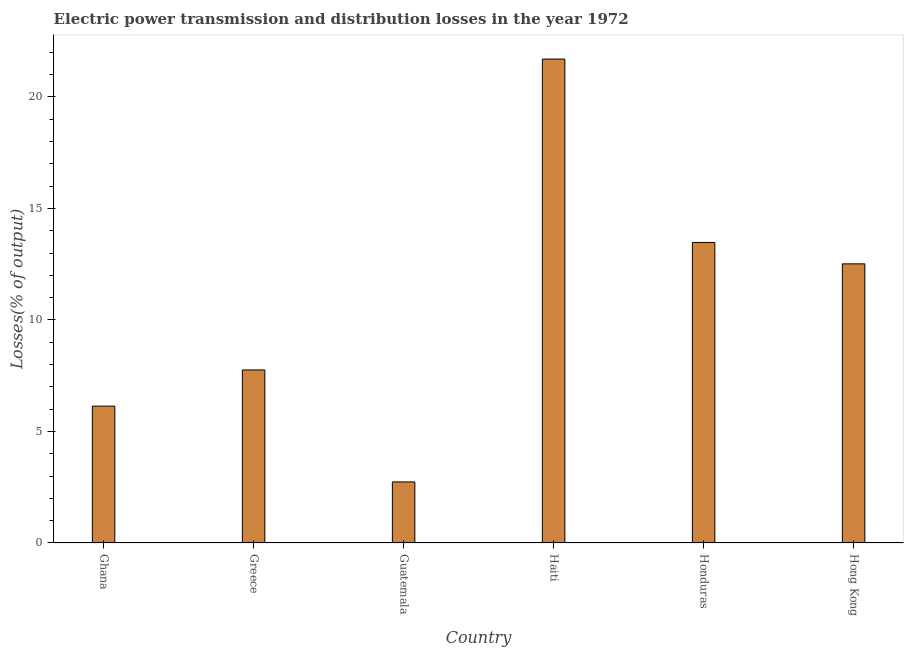What is the title of the graph?
Offer a very short reply. Electric power transmission and distribution losses in the year 1972. What is the label or title of the Y-axis?
Offer a very short reply. Losses(% of output). What is the electric power transmission and distribution losses in Honduras?
Your answer should be compact. 13.48. Across all countries, what is the maximum electric power transmission and distribution losses?
Offer a very short reply. 21.7. Across all countries, what is the minimum electric power transmission and distribution losses?
Keep it short and to the point. 2.74. In which country was the electric power transmission and distribution losses maximum?
Make the answer very short. Haiti. In which country was the electric power transmission and distribution losses minimum?
Make the answer very short. Guatemala. What is the sum of the electric power transmission and distribution losses?
Ensure brevity in your answer.  64.32. What is the difference between the electric power transmission and distribution losses in Haiti and Hong Kong?
Your response must be concise. 9.18. What is the average electric power transmission and distribution losses per country?
Make the answer very short. 10.72. What is the median electric power transmission and distribution losses?
Your answer should be very brief. 10.14. What is the ratio of the electric power transmission and distribution losses in Guatemala to that in Haiti?
Make the answer very short. 0.13. Is the electric power transmission and distribution losses in Guatemala less than that in Haiti?
Your response must be concise. Yes. Is the difference between the electric power transmission and distribution losses in Ghana and Guatemala greater than the difference between any two countries?
Your response must be concise. No. What is the difference between the highest and the second highest electric power transmission and distribution losses?
Keep it short and to the point. 8.22. What is the difference between the highest and the lowest electric power transmission and distribution losses?
Provide a succinct answer. 18.96. How many bars are there?
Offer a terse response. 6. How many countries are there in the graph?
Offer a very short reply. 6. What is the difference between two consecutive major ticks on the Y-axis?
Your answer should be compact. 5. What is the Losses(% of output) in Ghana?
Offer a very short reply. 6.14. What is the Losses(% of output) in Greece?
Ensure brevity in your answer.  7.76. What is the Losses(% of output) in Guatemala?
Provide a short and direct response. 2.74. What is the Losses(% of output) of Haiti?
Keep it short and to the point. 21.7. What is the Losses(% of output) in Honduras?
Give a very brief answer. 13.48. What is the Losses(% of output) of Hong Kong?
Offer a terse response. 12.52. What is the difference between the Losses(% of output) in Ghana and Greece?
Keep it short and to the point. -1.62. What is the difference between the Losses(% of output) in Ghana and Guatemala?
Provide a succinct answer. 3.4. What is the difference between the Losses(% of output) in Ghana and Haiti?
Provide a succinct answer. -15.56. What is the difference between the Losses(% of output) in Ghana and Honduras?
Provide a short and direct response. -7.34. What is the difference between the Losses(% of output) in Ghana and Hong Kong?
Ensure brevity in your answer.  -6.38. What is the difference between the Losses(% of output) in Greece and Guatemala?
Make the answer very short. 5.02. What is the difference between the Losses(% of output) in Greece and Haiti?
Your answer should be very brief. -13.94. What is the difference between the Losses(% of output) in Greece and Honduras?
Your response must be concise. -5.72. What is the difference between the Losses(% of output) in Greece and Hong Kong?
Offer a very short reply. -4.76. What is the difference between the Losses(% of output) in Guatemala and Haiti?
Provide a short and direct response. -18.96. What is the difference between the Losses(% of output) in Guatemala and Honduras?
Provide a succinct answer. -10.74. What is the difference between the Losses(% of output) in Guatemala and Hong Kong?
Your answer should be very brief. -9.78. What is the difference between the Losses(% of output) in Haiti and Honduras?
Make the answer very short. 8.22. What is the difference between the Losses(% of output) in Haiti and Hong Kong?
Keep it short and to the point. 9.18. What is the difference between the Losses(% of output) in Honduras and Hong Kong?
Give a very brief answer. 0.96. What is the ratio of the Losses(% of output) in Ghana to that in Greece?
Provide a succinct answer. 0.79. What is the ratio of the Losses(% of output) in Ghana to that in Guatemala?
Keep it short and to the point. 2.24. What is the ratio of the Losses(% of output) in Ghana to that in Haiti?
Your response must be concise. 0.28. What is the ratio of the Losses(% of output) in Ghana to that in Honduras?
Keep it short and to the point. 0.46. What is the ratio of the Losses(% of output) in Ghana to that in Hong Kong?
Provide a short and direct response. 0.49. What is the ratio of the Losses(% of output) in Greece to that in Guatemala?
Your response must be concise. 2.83. What is the ratio of the Losses(% of output) in Greece to that in Haiti?
Provide a short and direct response. 0.36. What is the ratio of the Losses(% of output) in Greece to that in Honduras?
Keep it short and to the point. 0.58. What is the ratio of the Losses(% of output) in Greece to that in Hong Kong?
Your response must be concise. 0.62. What is the ratio of the Losses(% of output) in Guatemala to that in Haiti?
Your answer should be compact. 0.13. What is the ratio of the Losses(% of output) in Guatemala to that in Honduras?
Offer a very short reply. 0.2. What is the ratio of the Losses(% of output) in Guatemala to that in Hong Kong?
Provide a succinct answer. 0.22. What is the ratio of the Losses(% of output) in Haiti to that in Honduras?
Your response must be concise. 1.61. What is the ratio of the Losses(% of output) in Haiti to that in Hong Kong?
Your response must be concise. 1.73. What is the ratio of the Losses(% of output) in Honduras to that in Hong Kong?
Provide a short and direct response. 1.08. 